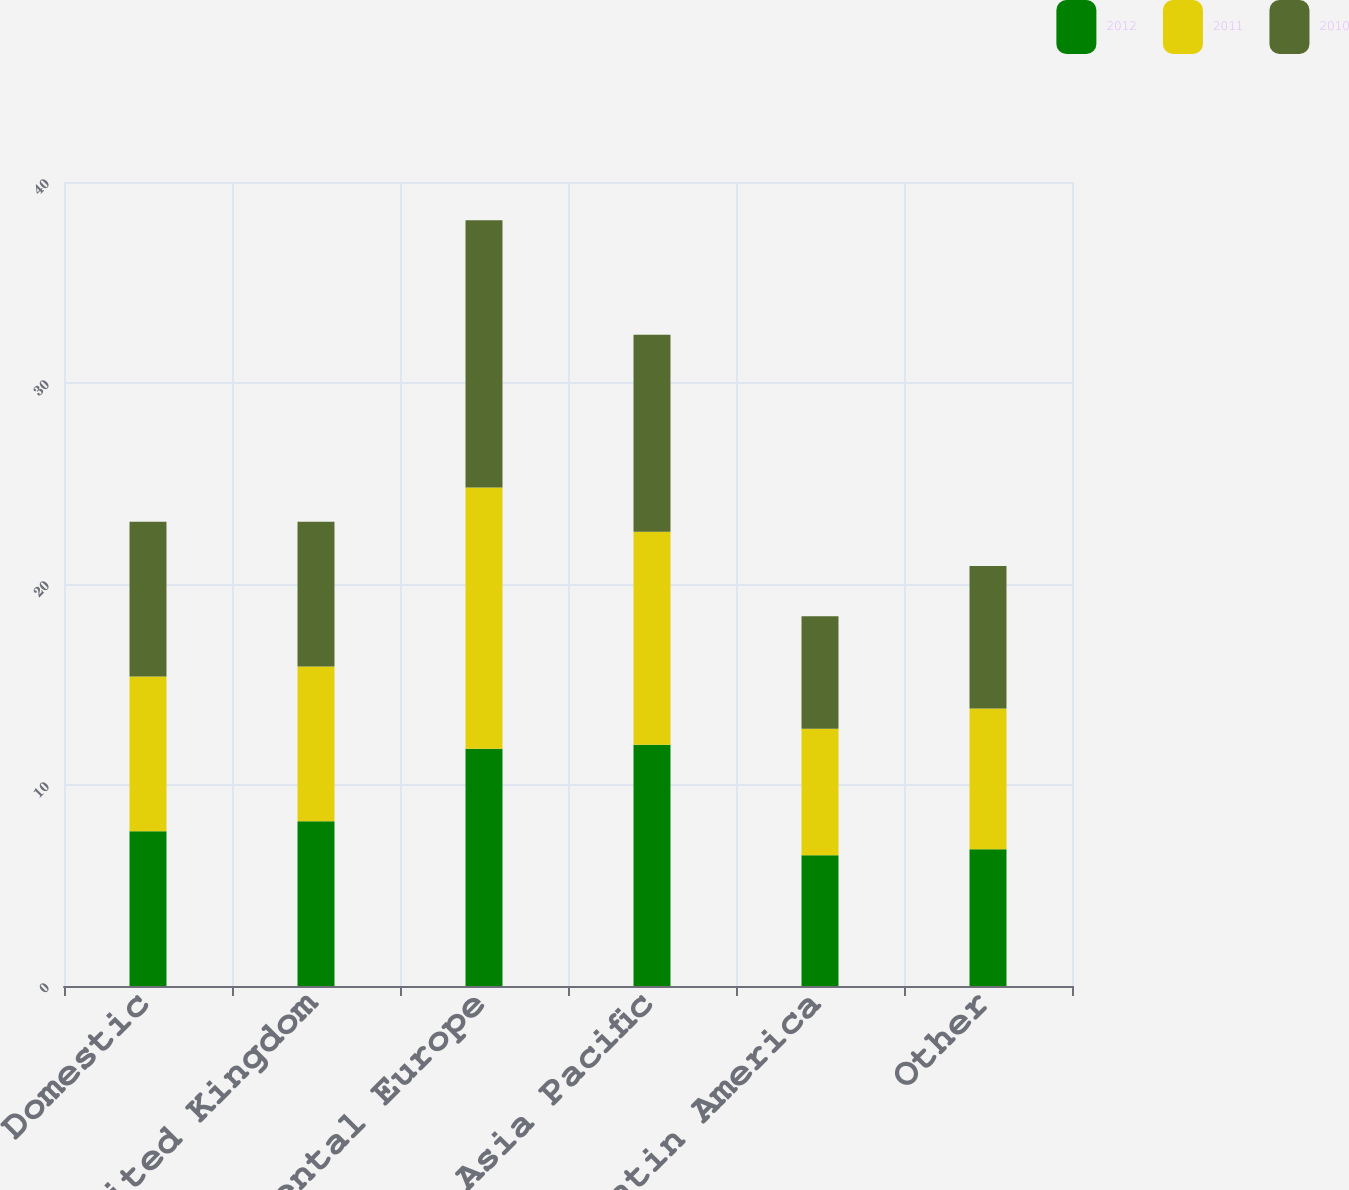<chart> <loc_0><loc_0><loc_500><loc_500><stacked_bar_chart><ecel><fcel>Domestic<fcel>United Kingdom<fcel>Continental Europe<fcel>Asia Pacific<fcel>Latin America<fcel>Other<nl><fcel>2012<fcel>7.7<fcel>8.2<fcel>11.8<fcel>12<fcel>6.5<fcel>6.8<nl><fcel>2011<fcel>7.7<fcel>7.7<fcel>13<fcel>10.6<fcel>6.3<fcel>7<nl><fcel>2010<fcel>7.7<fcel>7.2<fcel>13.3<fcel>9.8<fcel>5.6<fcel>7.1<nl></chart> 